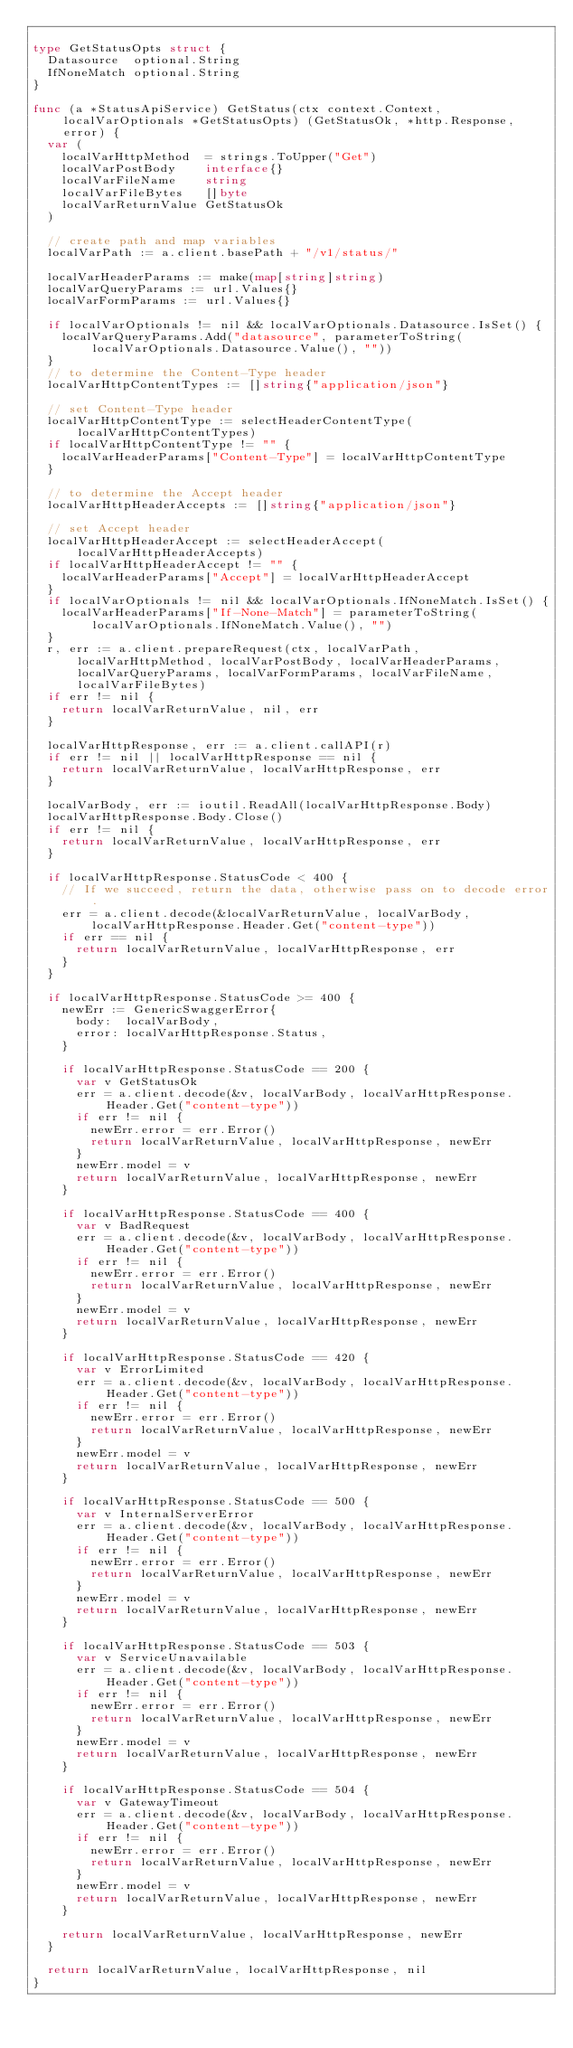<code> <loc_0><loc_0><loc_500><loc_500><_Go_>
type GetStatusOpts struct {
	Datasource  optional.String
	IfNoneMatch optional.String
}

func (a *StatusApiService) GetStatus(ctx context.Context, localVarOptionals *GetStatusOpts) (GetStatusOk, *http.Response, error) {
	var (
		localVarHttpMethod  = strings.ToUpper("Get")
		localVarPostBody    interface{}
		localVarFileName    string
		localVarFileBytes   []byte
		localVarReturnValue GetStatusOk
	)

	// create path and map variables
	localVarPath := a.client.basePath + "/v1/status/"

	localVarHeaderParams := make(map[string]string)
	localVarQueryParams := url.Values{}
	localVarFormParams := url.Values{}

	if localVarOptionals != nil && localVarOptionals.Datasource.IsSet() {
		localVarQueryParams.Add("datasource", parameterToString(localVarOptionals.Datasource.Value(), ""))
	}
	// to determine the Content-Type header
	localVarHttpContentTypes := []string{"application/json"}

	// set Content-Type header
	localVarHttpContentType := selectHeaderContentType(localVarHttpContentTypes)
	if localVarHttpContentType != "" {
		localVarHeaderParams["Content-Type"] = localVarHttpContentType
	}

	// to determine the Accept header
	localVarHttpHeaderAccepts := []string{"application/json"}

	// set Accept header
	localVarHttpHeaderAccept := selectHeaderAccept(localVarHttpHeaderAccepts)
	if localVarHttpHeaderAccept != "" {
		localVarHeaderParams["Accept"] = localVarHttpHeaderAccept
	}
	if localVarOptionals != nil && localVarOptionals.IfNoneMatch.IsSet() {
		localVarHeaderParams["If-None-Match"] = parameterToString(localVarOptionals.IfNoneMatch.Value(), "")
	}
	r, err := a.client.prepareRequest(ctx, localVarPath, localVarHttpMethod, localVarPostBody, localVarHeaderParams, localVarQueryParams, localVarFormParams, localVarFileName, localVarFileBytes)
	if err != nil {
		return localVarReturnValue, nil, err
	}

	localVarHttpResponse, err := a.client.callAPI(r)
	if err != nil || localVarHttpResponse == nil {
		return localVarReturnValue, localVarHttpResponse, err
	}

	localVarBody, err := ioutil.ReadAll(localVarHttpResponse.Body)
	localVarHttpResponse.Body.Close()
	if err != nil {
		return localVarReturnValue, localVarHttpResponse, err
	}

	if localVarHttpResponse.StatusCode < 400 {
		// If we succeed, return the data, otherwise pass on to decode error.
		err = a.client.decode(&localVarReturnValue, localVarBody, localVarHttpResponse.Header.Get("content-type"))
		if err == nil {
			return localVarReturnValue, localVarHttpResponse, err
		}
	}

	if localVarHttpResponse.StatusCode >= 400 {
		newErr := GenericSwaggerError{
			body:  localVarBody,
			error: localVarHttpResponse.Status,
		}

		if localVarHttpResponse.StatusCode == 200 {
			var v GetStatusOk
			err = a.client.decode(&v, localVarBody, localVarHttpResponse.Header.Get("content-type"))
			if err != nil {
				newErr.error = err.Error()
				return localVarReturnValue, localVarHttpResponse, newErr
			}
			newErr.model = v
			return localVarReturnValue, localVarHttpResponse, newErr
		}

		if localVarHttpResponse.StatusCode == 400 {
			var v BadRequest
			err = a.client.decode(&v, localVarBody, localVarHttpResponse.Header.Get("content-type"))
			if err != nil {
				newErr.error = err.Error()
				return localVarReturnValue, localVarHttpResponse, newErr
			}
			newErr.model = v
			return localVarReturnValue, localVarHttpResponse, newErr
		}

		if localVarHttpResponse.StatusCode == 420 {
			var v ErrorLimited
			err = a.client.decode(&v, localVarBody, localVarHttpResponse.Header.Get("content-type"))
			if err != nil {
				newErr.error = err.Error()
				return localVarReturnValue, localVarHttpResponse, newErr
			}
			newErr.model = v
			return localVarReturnValue, localVarHttpResponse, newErr
		}

		if localVarHttpResponse.StatusCode == 500 {
			var v InternalServerError
			err = a.client.decode(&v, localVarBody, localVarHttpResponse.Header.Get("content-type"))
			if err != nil {
				newErr.error = err.Error()
				return localVarReturnValue, localVarHttpResponse, newErr
			}
			newErr.model = v
			return localVarReturnValue, localVarHttpResponse, newErr
		}

		if localVarHttpResponse.StatusCode == 503 {
			var v ServiceUnavailable
			err = a.client.decode(&v, localVarBody, localVarHttpResponse.Header.Get("content-type"))
			if err != nil {
				newErr.error = err.Error()
				return localVarReturnValue, localVarHttpResponse, newErr
			}
			newErr.model = v
			return localVarReturnValue, localVarHttpResponse, newErr
		}

		if localVarHttpResponse.StatusCode == 504 {
			var v GatewayTimeout
			err = a.client.decode(&v, localVarBody, localVarHttpResponse.Header.Get("content-type"))
			if err != nil {
				newErr.error = err.Error()
				return localVarReturnValue, localVarHttpResponse, newErr
			}
			newErr.model = v
			return localVarReturnValue, localVarHttpResponse, newErr
		}

		return localVarReturnValue, localVarHttpResponse, newErr
	}

	return localVarReturnValue, localVarHttpResponse, nil
}
</code> 